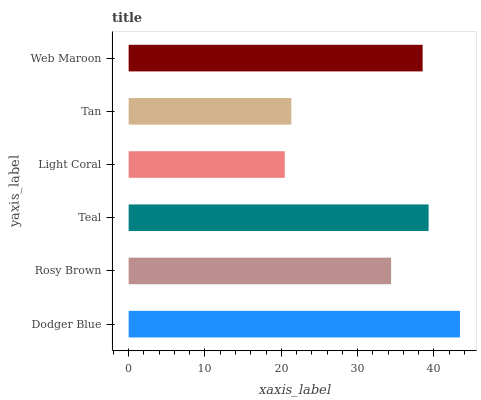Is Light Coral the minimum?
Answer yes or no. Yes. Is Dodger Blue the maximum?
Answer yes or no. Yes. Is Rosy Brown the minimum?
Answer yes or no. No. Is Rosy Brown the maximum?
Answer yes or no. No. Is Dodger Blue greater than Rosy Brown?
Answer yes or no. Yes. Is Rosy Brown less than Dodger Blue?
Answer yes or no. Yes. Is Rosy Brown greater than Dodger Blue?
Answer yes or no. No. Is Dodger Blue less than Rosy Brown?
Answer yes or no. No. Is Web Maroon the high median?
Answer yes or no. Yes. Is Rosy Brown the low median?
Answer yes or no. Yes. Is Rosy Brown the high median?
Answer yes or no. No. Is Teal the low median?
Answer yes or no. No. 